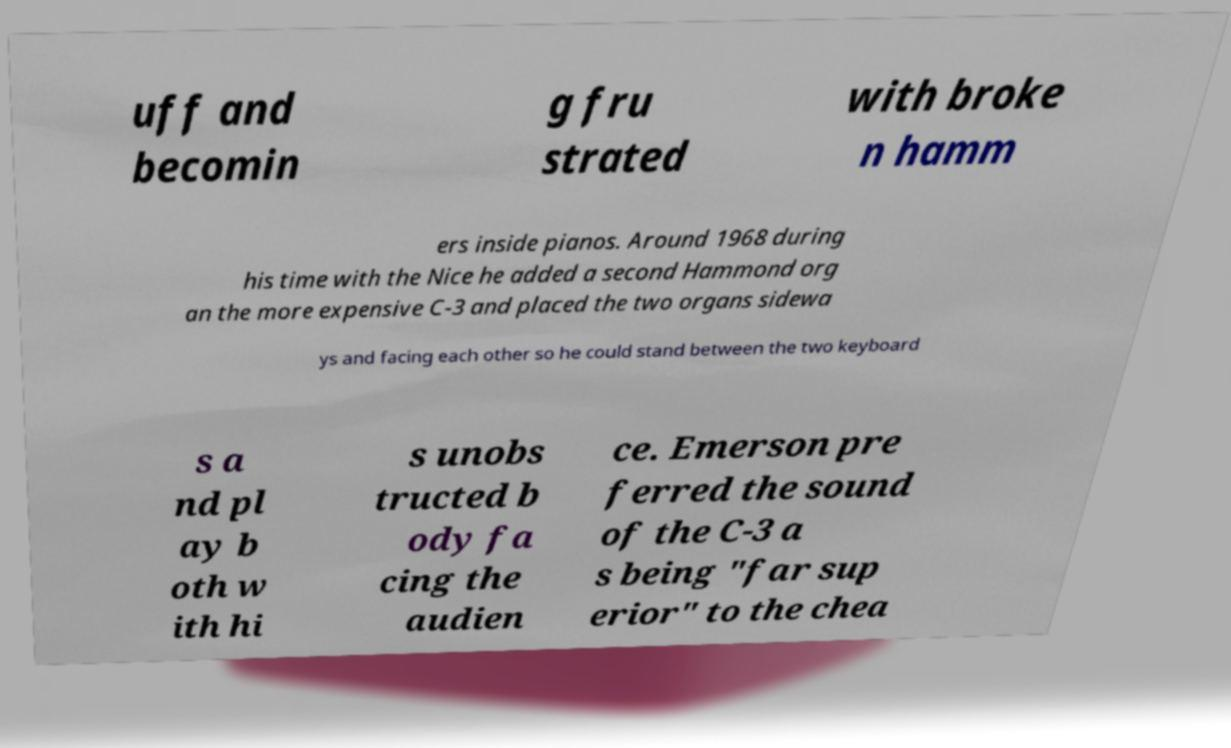What messages or text are displayed in this image? I need them in a readable, typed format. uff and becomin g fru strated with broke n hamm ers inside pianos. Around 1968 during his time with the Nice he added a second Hammond org an the more expensive C-3 and placed the two organs sidewa ys and facing each other so he could stand between the two keyboard s a nd pl ay b oth w ith hi s unobs tructed b ody fa cing the audien ce. Emerson pre ferred the sound of the C-3 a s being "far sup erior" to the chea 